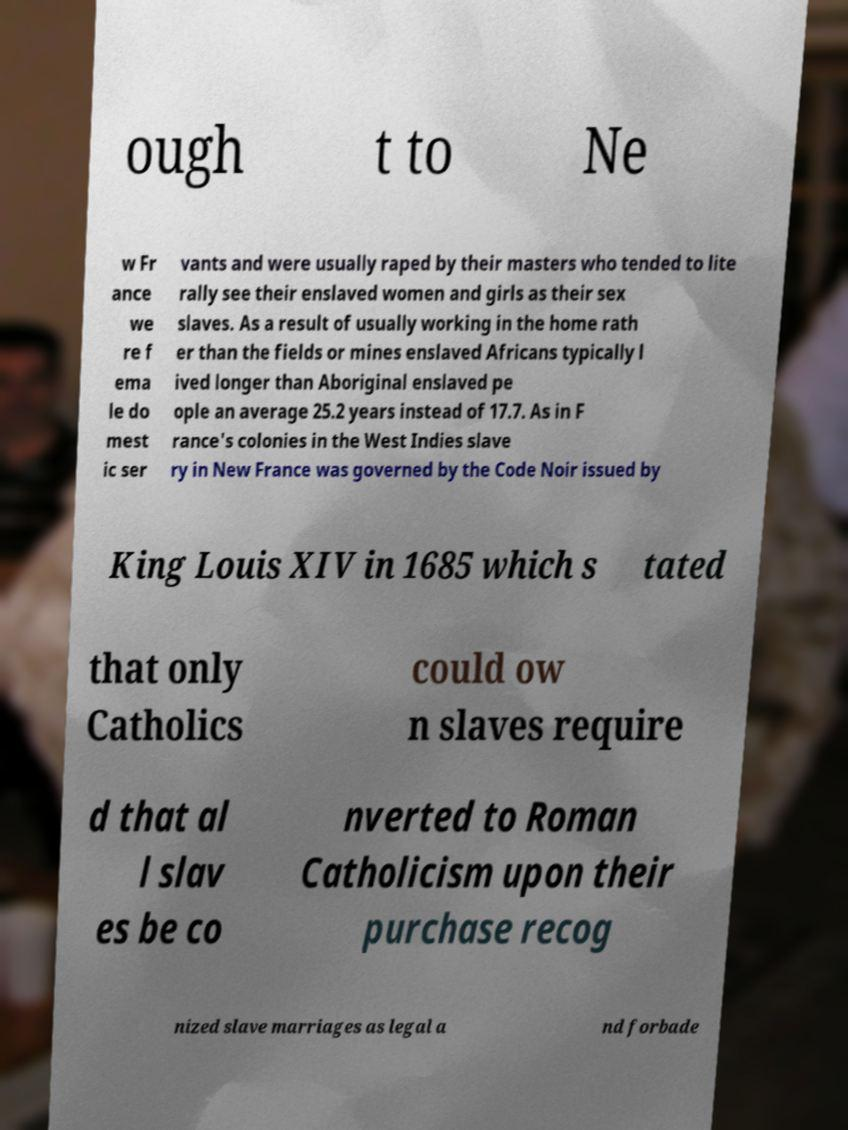Could you extract and type out the text from this image? ough t to Ne w Fr ance we re f ema le do mest ic ser vants and were usually raped by their masters who tended to lite rally see their enslaved women and girls as their sex slaves. As a result of usually working in the home rath er than the fields or mines enslaved Africans typically l ived longer than Aboriginal enslaved pe ople an average 25.2 years instead of 17.7. As in F rance's colonies in the West Indies slave ry in New France was governed by the Code Noir issued by King Louis XIV in 1685 which s tated that only Catholics could ow n slaves require d that al l slav es be co nverted to Roman Catholicism upon their purchase recog nized slave marriages as legal a nd forbade 